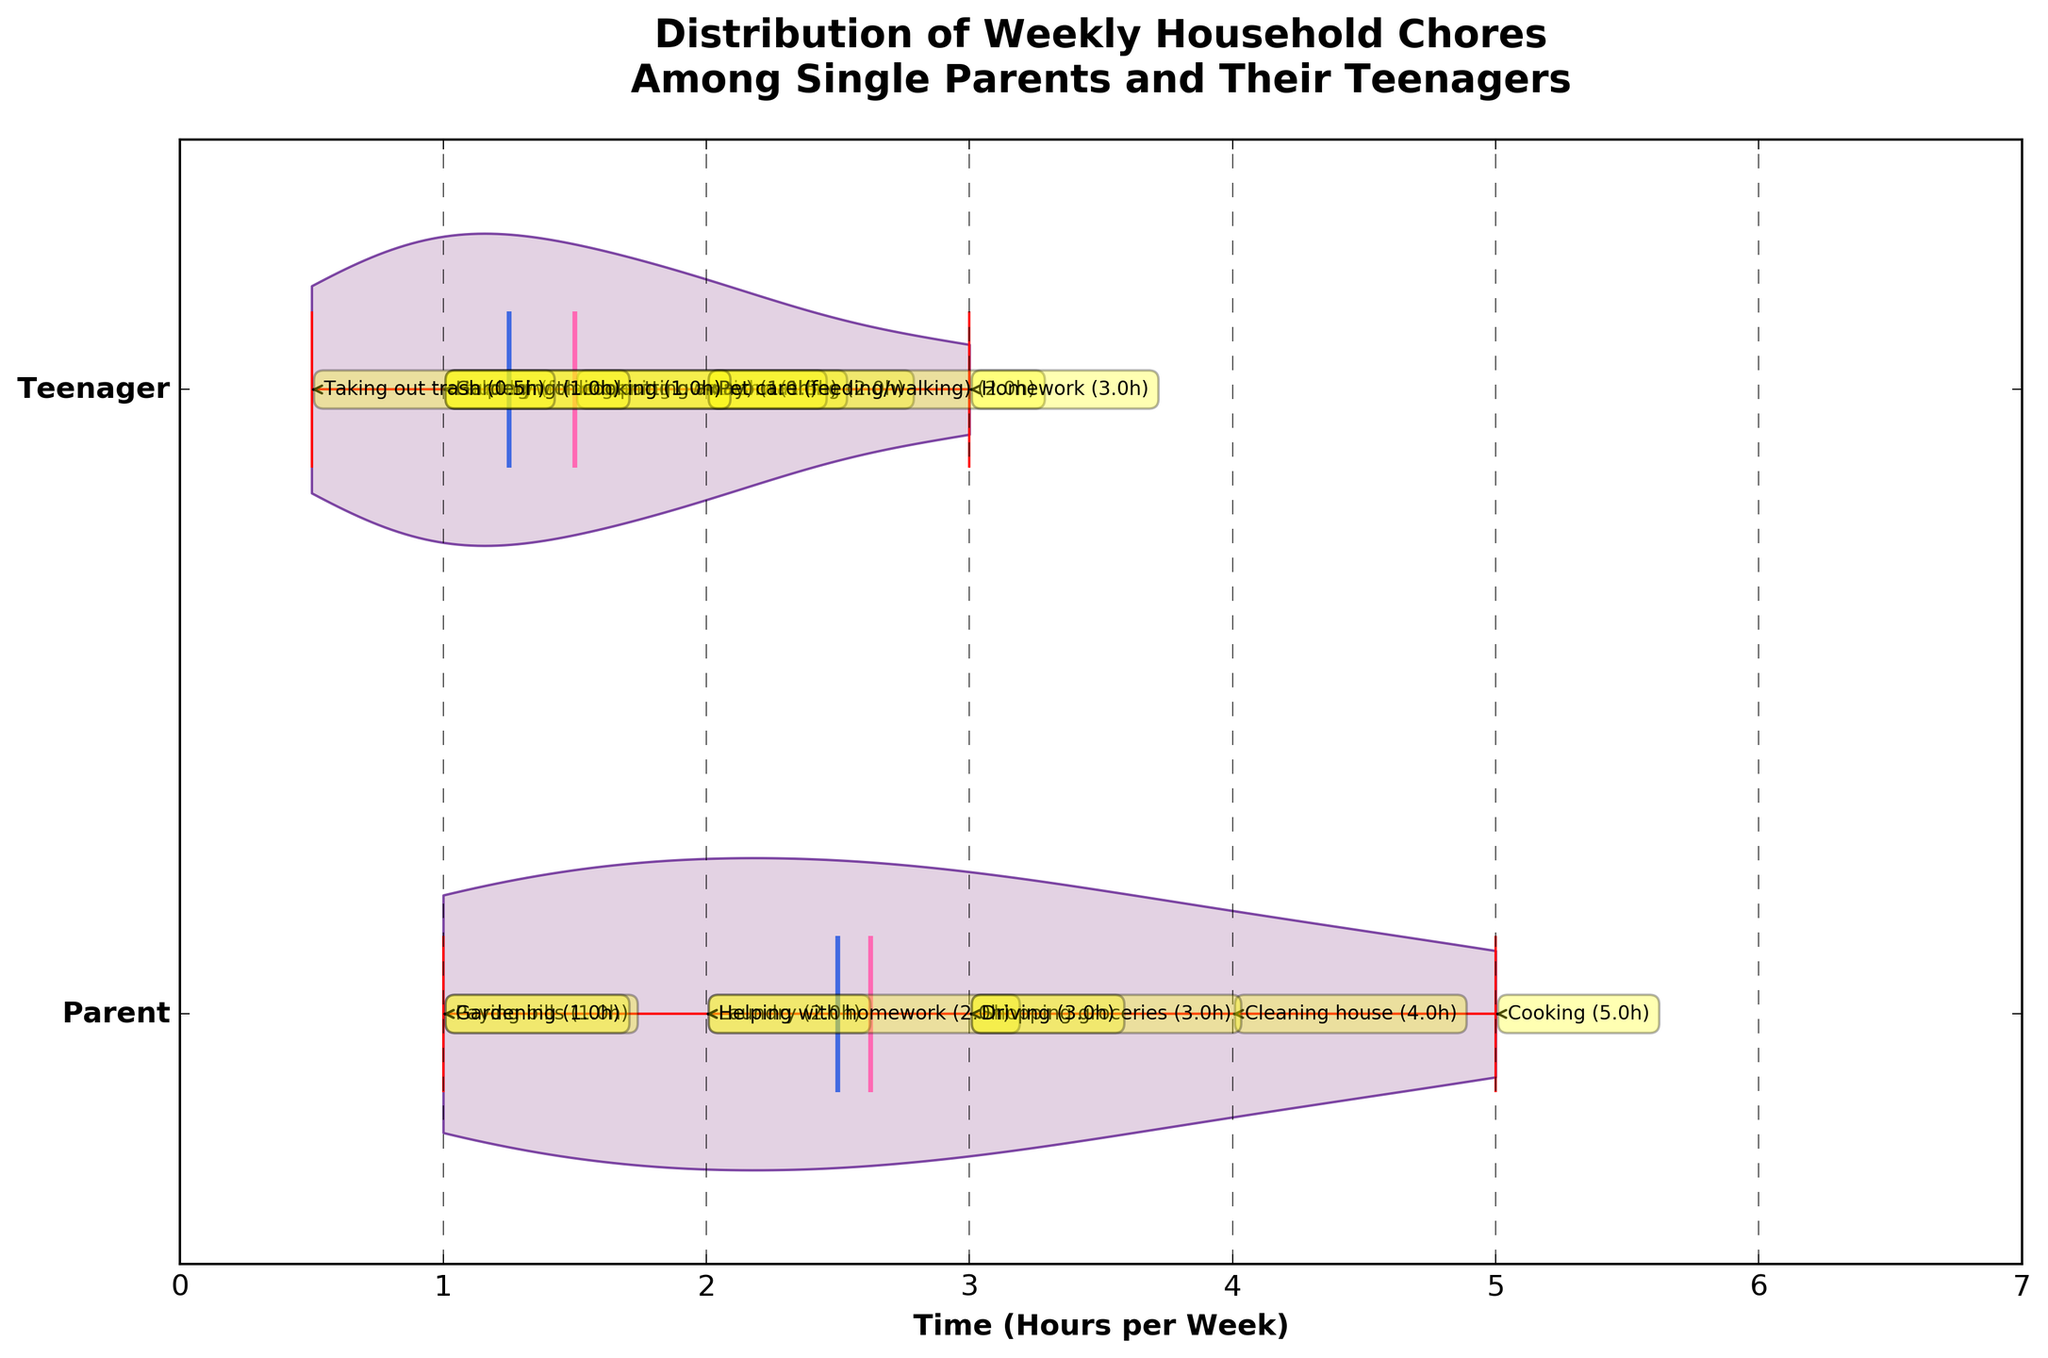What is the total number of hours spent on cooking by both the parent and the teenager combined? The parent spends 5 hours on cooking, and the teenager spends 1 hour on helping with cooking. Adding these together gives us 5 + 1.
Answer: 6 hours What task does the parent spend the most time on? By looking at the annotated tasks, the parent spends the most time on cooking, which is 5 hours per week.
Answer: Cooking What's the mean weekly chore time for the parent? Summing up the parent's chore times (5 + 4 + 3 + 2 + 1 + 2 + 1 + 3) gives 21 hours. There are 8 tasks, so dividing by 8 gives 21/8 = 2.625 hours.
Answer: 2.6 hours Which group has the highest spread in the distribution of their chores? By looking at the violins, the parent's group has a wider spread compared to the teenager's group.
Answer: Parent How many hours in total does the teenager spend on chores involving animals? The teenager spends 2 hours on pet care (feeding/walking). This is the only animal-related chore mentioned.
Answer: 2 hours Which task does the teenager spend the least amount of time on? The teenager spends the least amount of time on taking out trash, which is 0.5 hours per week.
Answer: Taking out trash What is the median weekly chore time for teenagers? The plot shows the median lines within the violin shapes. For teenagers, the median chore time is noticeably around 1.5 hours per week.
Answer: 1.5 hours How many more hours does the parent spend on shopping groceries compared to the driving task? The parent spends 3 hours on shopping groceries and 3 hours on driving. The difference is 3 - 3 = 0 hours.
Answer: 0 hours What is the title of the chart? The title is written at the top of the chart. It reads "Distribution of Weekly Household Chores Among Single Parents and Their Teenagers".
Answer: Distribution of Weekly Household Chores Among Single Parents and Their Teenagers Which task has the biggest difference in time spent between the parent and the teenager? By comparing the annotated tasks, cooking has the most significant difference. The parent spends 5 hours, while the teenager spends 1 hour. The difference is 5 - 1 = 4 hours.
Answer: Cooking (4 hours) 